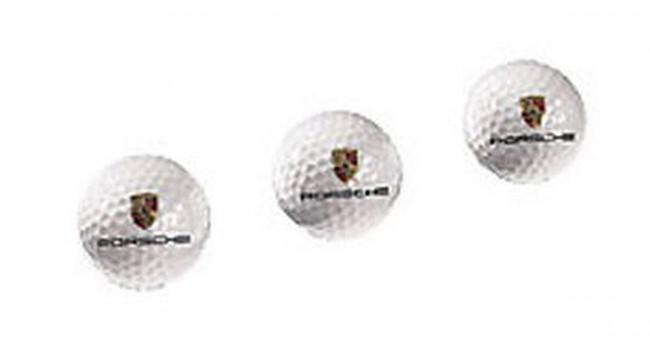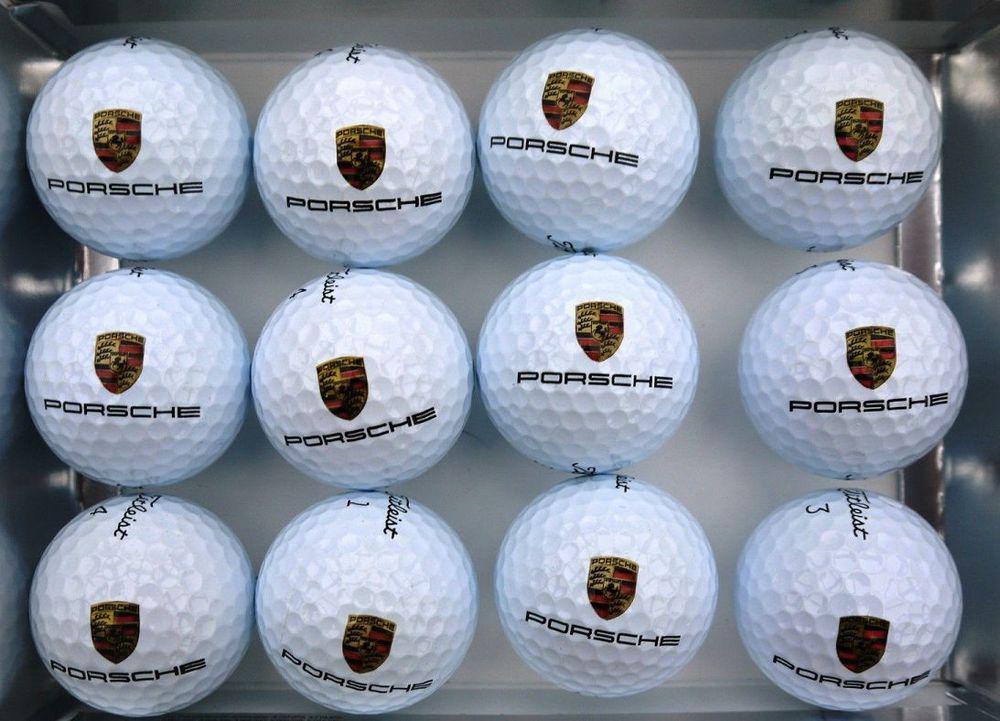The first image is the image on the left, the second image is the image on the right. Examine the images to the left and right. Is the description "The right image contains at least three golf balls." accurate? Answer yes or no. Yes. The first image is the image on the left, the second image is the image on the right. Examine the images to the left and right. Is the description "An image shows a group of exactly three white golf balls with the same logos printed on them." accurate? Answer yes or no. Yes. 